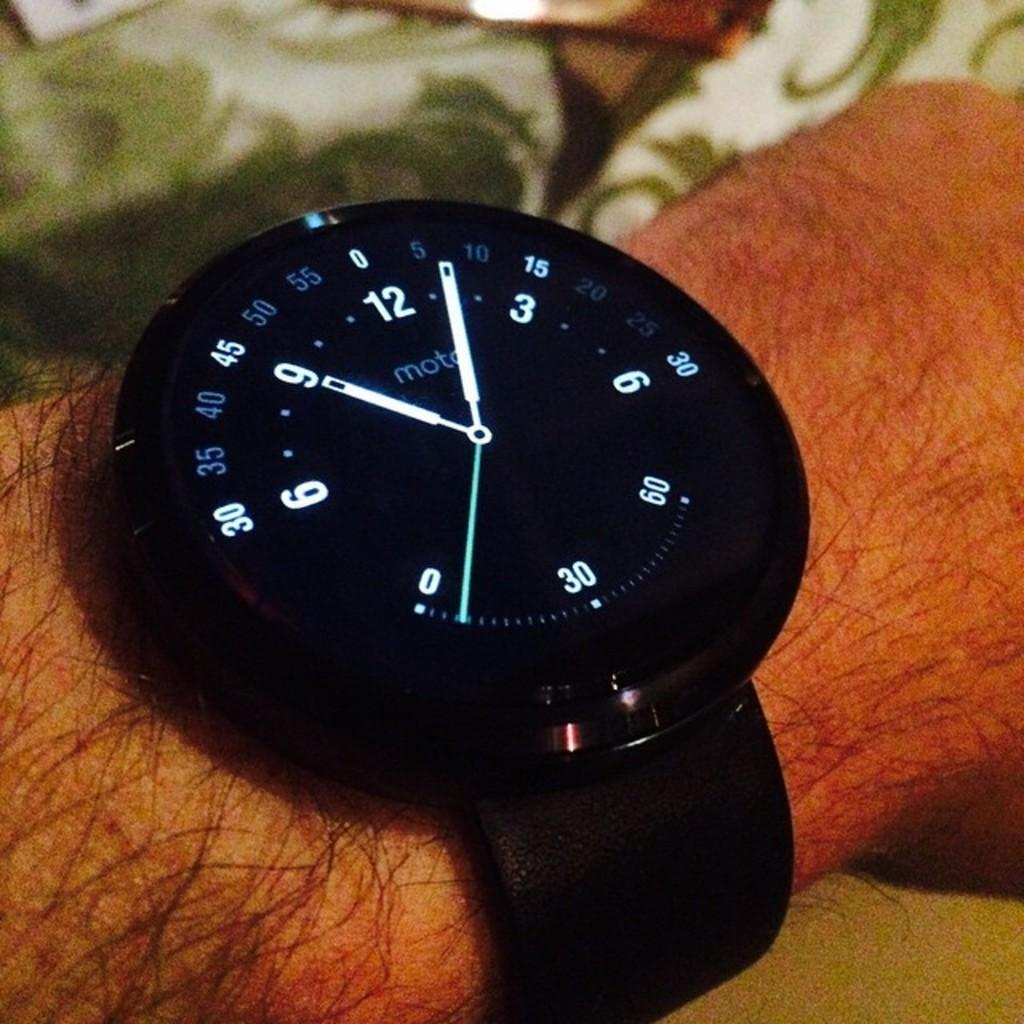Provide a one-sentence caption for the provided image. a Moto black analog wrist watch on a hairy arm. 